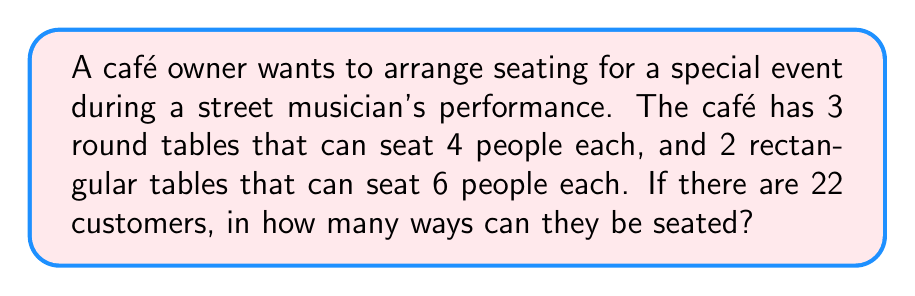Can you solve this math problem? Let's approach this step-by-step:

1) First, we need to choose which 22 out of the 24 available seats will be occupied.
   This can be done in $\binom{24}{22}$ ways.

2) Now, for each of these choices, we need to arrange the 22 people in the chosen seats.
   This is a permutation of 22 people, which can be done in 22! ways.

3) However, the people seated at each table can be arranged among themselves without 
   creating a new overall arrangement. We need to divide by these internal arrangements:
   - For each round table: 4! arrangements
   - For each rectangular table: 6! arrangements

4) Putting this all together, the total number of arrangements is:

   $$\frac{\binom{24}{22} \cdot 22!}{(4!)^3 \cdot (6!)^2}$$

5) Let's calculate this:
   $$\begin{align}
   &= \frac{276 \cdot 22!}{24 \cdot 24 \cdot 24 \cdot 720 \cdot 720} \\
   &= \frac{276 \cdot 22!}{9,953,280} \\
   &= 3,879,876,043,964
   \end{align}$$
Answer: 3,879,876,043,964 